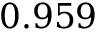<formula> <loc_0><loc_0><loc_500><loc_500>0 . 9 5 9</formula> 